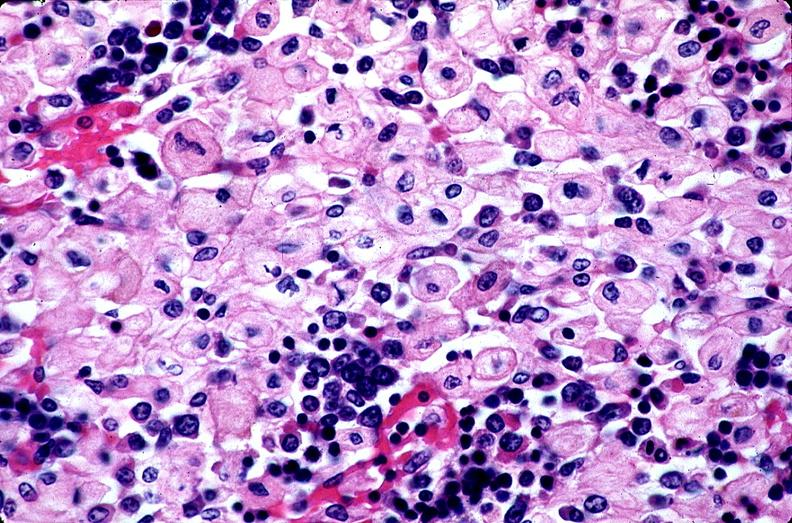does squamous cell carcinoma show gaucher disease?
Answer the question using a single word or phrase. No 